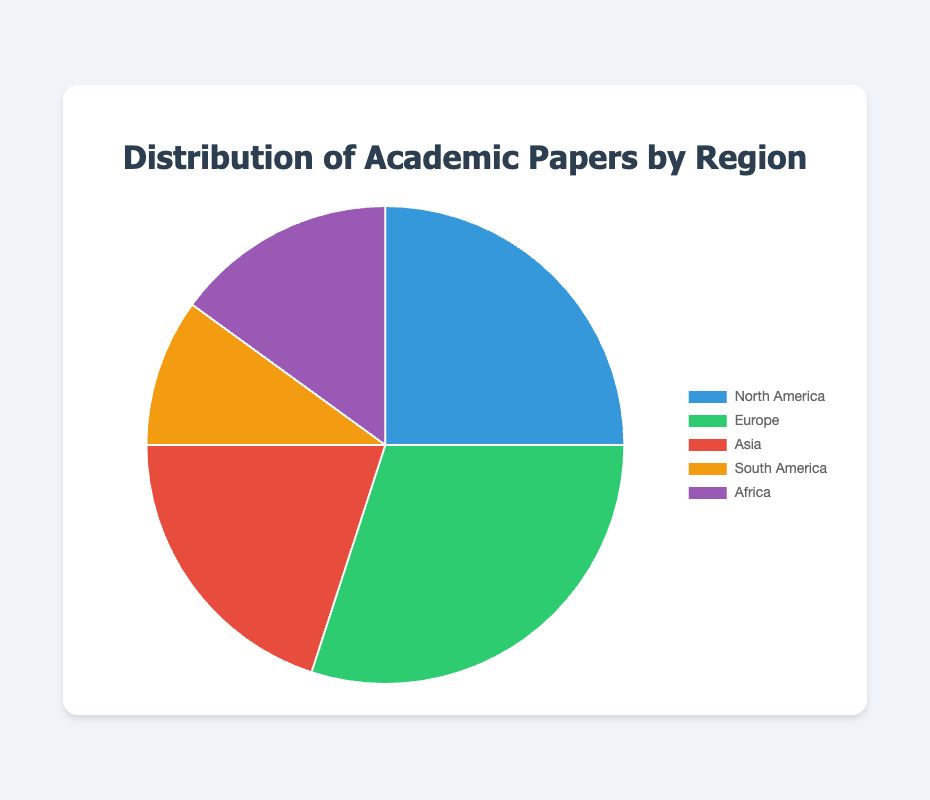What is the percentage of academic papers coming from Europe? The pie chart shows the percentage distribution of academic papers by region. Europe is one of these regions and its associated percentage slice is labeled.
Answer: 30% Which region has the smallest percentage of academic papers? By comparing the sizes of the slices in the pie chart or their labels, South America's slice appears to be the smallest.
Answer: South America How much greater is the percentage of academic papers from Europe compared to Asia? Europe's slice represents 30% and Asia's slice represents 20%. The difference is 30% - 20%.
Answer: 10% What is the combined percentage of academic papers from Africa and South America? Africa has a percentage of 15%, and South America has a percentage of 10%. The sum of these two percentages is 15% + 10%.
Answer: 25% Which regions contribute to more than half of the total academic papers? Adding up the percentages for each region, Europe (30%) and North America (25%) together account for 55%. This combined percentage is more than half of the total.
Answer: Europe and North America Is the percentage of academic papers from Asia less than from Africa? Asia's slice is labeled 20%, while Africa's slice is labeled 15%. Comparing the two values, 20% from Asia is greater than 15% from Africa.
Answer: No What is the sum of the percentages of academic papers from North America, Europe, and Asia? North America contributes 25%, Europe 30%, and Asia 20%. Summing these percentages: 25% + 30% + 20% gives 75%.
Answer: 75% How many regions contribute to the distribution of academic papers shown in the pie chart? By counting the labeled slices of the pie chart, there are five regions.
Answer: 5 Which region's slice is represented by a purple color? The pie chart uses specific colors for each region, and Africa is represented by a purple-colored slice.
Answer: Africa What is the average percentage of academic papers per region? Summing all the percentages: 25% (North America) + 30% (Europe) + 20% (Asia) + 10% (South America) + 15% (Africa) totals 100%. Dividing this sum by the number of regions (5) results in an average of 100% / 5 = 20%.
Answer: 20% 